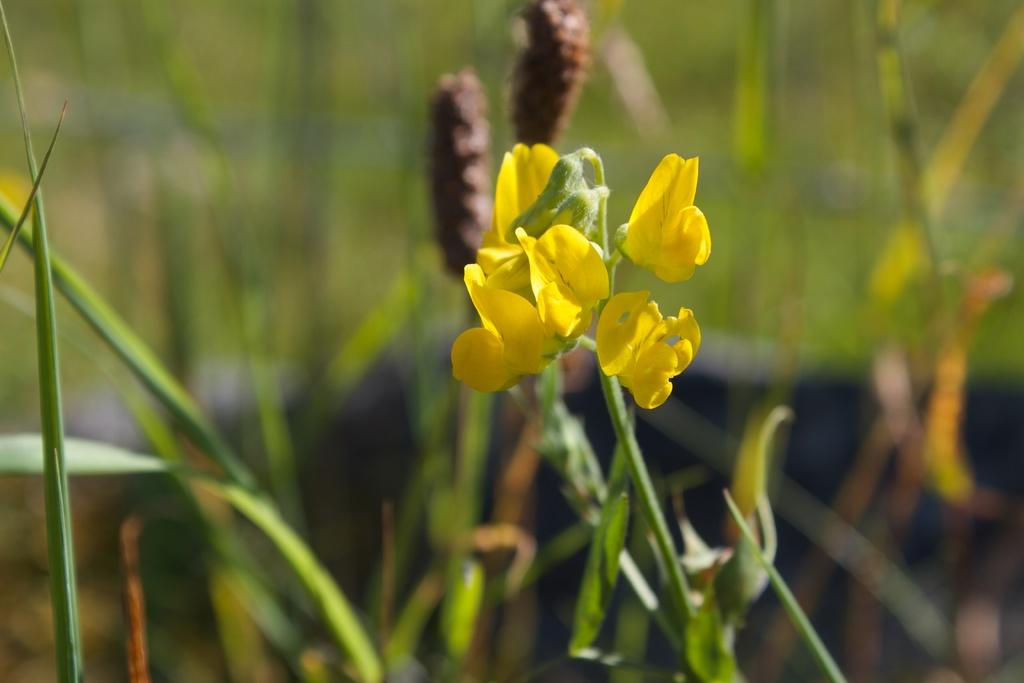What type of flowers can be seen in the image? There are flowers in the image, including buds. What structures are present in the image? There are tents in the image. What else can be found in the image besides flowers and tents? There are plants in the image. What can be seen in the background of the image? There is greenery in the background of the image. Where is the island located in the image? There is no island present in the image. What rule is being enforced in the image? There is no rule being enforced in the image. 